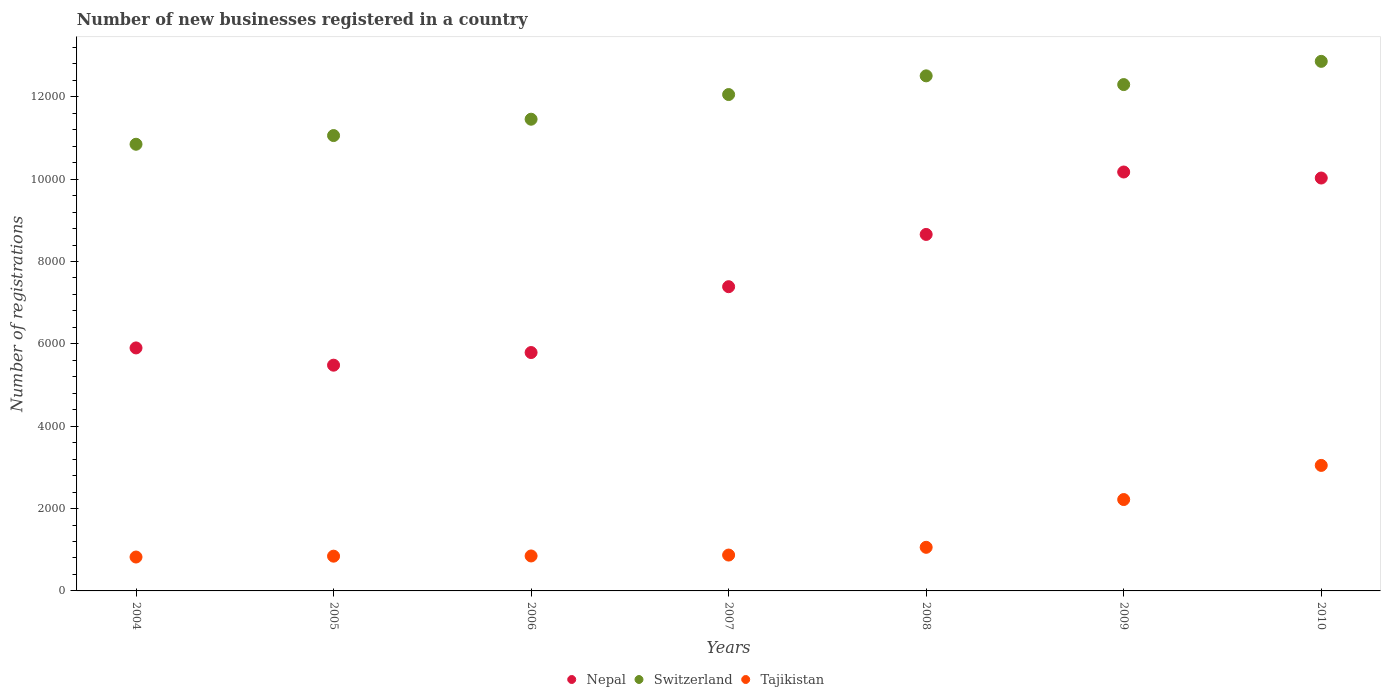What is the number of new businesses registered in Tajikistan in 2004?
Provide a succinct answer. 823. Across all years, what is the maximum number of new businesses registered in Nepal?
Provide a short and direct response. 1.02e+04. Across all years, what is the minimum number of new businesses registered in Switzerland?
Provide a succinct answer. 1.08e+04. What is the total number of new businesses registered in Nepal in the graph?
Give a very brief answer. 5.34e+04. What is the difference between the number of new businesses registered in Nepal in 2004 and that in 2008?
Offer a very short reply. -2756. What is the difference between the number of new businesses registered in Nepal in 2009 and the number of new businesses registered in Switzerland in 2010?
Your answer should be compact. -2687. What is the average number of new businesses registered in Switzerland per year?
Offer a terse response. 1.19e+04. In the year 2009, what is the difference between the number of new businesses registered in Switzerland and number of new businesses registered in Tajikistan?
Provide a succinct answer. 1.01e+04. What is the ratio of the number of new businesses registered in Nepal in 2005 to that in 2010?
Your answer should be compact. 0.55. What is the difference between the highest and the second highest number of new businesses registered in Switzerland?
Provide a succinct answer. 352. What is the difference between the highest and the lowest number of new businesses registered in Nepal?
Give a very brief answer. 4691. Is the sum of the number of new businesses registered in Nepal in 2004 and 2005 greater than the maximum number of new businesses registered in Switzerland across all years?
Provide a short and direct response. No. Does the number of new businesses registered in Switzerland monotonically increase over the years?
Give a very brief answer. No. How many dotlines are there?
Ensure brevity in your answer.  3. How many years are there in the graph?
Offer a terse response. 7. What is the difference between two consecutive major ticks on the Y-axis?
Offer a terse response. 2000. Are the values on the major ticks of Y-axis written in scientific E-notation?
Ensure brevity in your answer.  No. Where does the legend appear in the graph?
Keep it short and to the point. Bottom center. What is the title of the graph?
Ensure brevity in your answer.  Number of new businesses registered in a country. What is the label or title of the X-axis?
Your answer should be very brief. Years. What is the label or title of the Y-axis?
Your answer should be compact. Number of registrations. What is the Number of registrations in Nepal in 2004?
Provide a short and direct response. 5901. What is the Number of registrations in Switzerland in 2004?
Ensure brevity in your answer.  1.08e+04. What is the Number of registrations of Tajikistan in 2004?
Ensure brevity in your answer.  823. What is the Number of registrations in Nepal in 2005?
Provide a succinct answer. 5482. What is the Number of registrations in Switzerland in 2005?
Your response must be concise. 1.11e+04. What is the Number of registrations in Tajikistan in 2005?
Ensure brevity in your answer.  844. What is the Number of registrations of Nepal in 2006?
Your answer should be very brief. 5789. What is the Number of registrations of Switzerland in 2006?
Provide a succinct answer. 1.15e+04. What is the Number of registrations in Tajikistan in 2006?
Make the answer very short. 849. What is the Number of registrations in Nepal in 2007?
Provide a succinct answer. 7388. What is the Number of registrations of Switzerland in 2007?
Keep it short and to the point. 1.21e+04. What is the Number of registrations of Tajikistan in 2007?
Your response must be concise. 871. What is the Number of registrations of Nepal in 2008?
Ensure brevity in your answer.  8657. What is the Number of registrations in Switzerland in 2008?
Your answer should be very brief. 1.25e+04. What is the Number of registrations of Tajikistan in 2008?
Your answer should be very brief. 1059. What is the Number of registrations of Nepal in 2009?
Give a very brief answer. 1.02e+04. What is the Number of registrations in Switzerland in 2009?
Offer a very short reply. 1.23e+04. What is the Number of registrations in Tajikistan in 2009?
Make the answer very short. 2219. What is the Number of registrations in Nepal in 2010?
Your answer should be very brief. 1.00e+04. What is the Number of registrations of Switzerland in 2010?
Your response must be concise. 1.29e+04. What is the Number of registrations in Tajikistan in 2010?
Offer a terse response. 3048. Across all years, what is the maximum Number of registrations in Nepal?
Your answer should be very brief. 1.02e+04. Across all years, what is the maximum Number of registrations of Switzerland?
Provide a short and direct response. 1.29e+04. Across all years, what is the maximum Number of registrations of Tajikistan?
Your answer should be compact. 3048. Across all years, what is the minimum Number of registrations of Nepal?
Offer a very short reply. 5482. Across all years, what is the minimum Number of registrations of Switzerland?
Offer a terse response. 1.08e+04. Across all years, what is the minimum Number of registrations of Tajikistan?
Ensure brevity in your answer.  823. What is the total Number of registrations of Nepal in the graph?
Provide a short and direct response. 5.34e+04. What is the total Number of registrations of Switzerland in the graph?
Your answer should be compact. 8.31e+04. What is the total Number of registrations of Tajikistan in the graph?
Offer a terse response. 9713. What is the difference between the Number of registrations of Nepal in 2004 and that in 2005?
Your answer should be compact. 419. What is the difference between the Number of registrations in Switzerland in 2004 and that in 2005?
Provide a short and direct response. -211. What is the difference between the Number of registrations in Tajikistan in 2004 and that in 2005?
Offer a terse response. -21. What is the difference between the Number of registrations in Nepal in 2004 and that in 2006?
Keep it short and to the point. 112. What is the difference between the Number of registrations of Switzerland in 2004 and that in 2006?
Your response must be concise. -608. What is the difference between the Number of registrations of Tajikistan in 2004 and that in 2006?
Provide a short and direct response. -26. What is the difference between the Number of registrations in Nepal in 2004 and that in 2007?
Ensure brevity in your answer.  -1487. What is the difference between the Number of registrations of Switzerland in 2004 and that in 2007?
Your response must be concise. -1207. What is the difference between the Number of registrations in Tajikistan in 2004 and that in 2007?
Offer a very short reply. -48. What is the difference between the Number of registrations in Nepal in 2004 and that in 2008?
Your answer should be very brief. -2756. What is the difference between the Number of registrations in Switzerland in 2004 and that in 2008?
Provide a succinct answer. -1661. What is the difference between the Number of registrations of Tajikistan in 2004 and that in 2008?
Provide a succinct answer. -236. What is the difference between the Number of registrations in Nepal in 2004 and that in 2009?
Your answer should be very brief. -4272. What is the difference between the Number of registrations in Switzerland in 2004 and that in 2009?
Make the answer very short. -1449. What is the difference between the Number of registrations in Tajikistan in 2004 and that in 2009?
Ensure brevity in your answer.  -1396. What is the difference between the Number of registrations of Nepal in 2004 and that in 2010?
Offer a very short reply. -4126. What is the difference between the Number of registrations in Switzerland in 2004 and that in 2010?
Provide a succinct answer. -2013. What is the difference between the Number of registrations of Tajikistan in 2004 and that in 2010?
Ensure brevity in your answer.  -2225. What is the difference between the Number of registrations in Nepal in 2005 and that in 2006?
Provide a succinct answer. -307. What is the difference between the Number of registrations in Switzerland in 2005 and that in 2006?
Give a very brief answer. -397. What is the difference between the Number of registrations of Tajikistan in 2005 and that in 2006?
Your response must be concise. -5. What is the difference between the Number of registrations in Nepal in 2005 and that in 2007?
Ensure brevity in your answer.  -1906. What is the difference between the Number of registrations of Switzerland in 2005 and that in 2007?
Offer a terse response. -996. What is the difference between the Number of registrations in Tajikistan in 2005 and that in 2007?
Your answer should be very brief. -27. What is the difference between the Number of registrations of Nepal in 2005 and that in 2008?
Provide a succinct answer. -3175. What is the difference between the Number of registrations of Switzerland in 2005 and that in 2008?
Your answer should be compact. -1450. What is the difference between the Number of registrations of Tajikistan in 2005 and that in 2008?
Make the answer very short. -215. What is the difference between the Number of registrations in Nepal in 2005 and that in 2009?
Your answer should be compact. -4691. What is the difference between the Number of registrations of Switzerland in 2005 and that in 2009?
Your response must be concise. -1238. What is the difference between the Number of registrations of Tajikistan in 2005 and that in 2009?
Offer a terse response. -1375. What is the difference between the Number of registrations of Nepal in 2005 and that in 2010?
Make the answer very short. -4545. What is the difference between the Number of registrations of Switzerland in 2005 and that in 2010?
Give a very brief answer. -1802. What is the difference between the Number of registrations of Tajikistan in 2005 and that in 2010?
Your answer should be very brief. -2204. What is the difference between the Number of registrations in Nepal in 2006 and that in 2007?
Keep it short and to the point. -1599. What is the difference between the Number of registrations of Switzerland in 2006 and that in 2007?
Offer a very short reply. -599. What is the difference between the Number of registrations in Nepal in 2006 and that in 2008?
Offer a terse response. -2868. What is the difference between the Number of registrations in Switzerland in 2006 and that in 2008?
Provide a succinct answer. -1053. What is the difference between the Number of registrations in Tajikistan in 2006 and that in 2008?
Ensure brevity in your answer.  -210. What is the difference between the Number of registrations in Nepal in 2006 and that in 2009?
Make the answer very short. -4384. What is the difference between the Number of registrations of Switzerland in 2006 and that in 2009?
Your answer should be very brief. -841. What is the difference between the Number of registrations in Tajikistan in 2006 and that in 2009?
Ensure brevity in your answer.  -1370. What is the difference between the Number of registrations of Nepal in 2006 and that in 2010?
Your answer should be very brief. -4238. What is the difference between the Number of registrations in Switzerland in 2006 and that in 2010?
Offer a terse response. -1405. What is the difference between the Number of registrations in Tajikistan in 2006 and that in 2010?
Keep it short and to the point. -2199. What is the difference between the Number of registrations of Nepal in 2007 and that in 2008?
Ensure brevity in your answer.  -1269. What is the difference between the Number of registrations in Switzerland in 2007 and that in 2008?
Offer a terse response. -454. What is the difference between the Number of registrations in Tajikistan in 2007 and that in 2008?
Provide a succinct answer. -188. What is the difference between the Number of registrations of Nepal in 2007 and that in 2009?
Your answer should be compact. -2785. What is the difference between the Number of registrations in Switzerland in 2007 and that in 2009?
Provide a short and direct response. -242. What is the difference between the Number of registrations of Tajikistan in 2007 and that in 2009?
Ensure brevity in your answer.  -1348. What is the difference between the Number of registrations in Nepal in 2007 and that in 2010?
Your answer should be compact. -2639. What is the difference between the Number of registrations of Switzerland in 2007 and that in 2010?
Offer a terse response. -806. What is the difference between the Number of registrations of Tajikistan in 2007 and that in 2010?
Ensure brevity in your answer.  -2177. What is the difference between the Number of registrations of Nepal in 2008 and that in 2009?
Offer a very short reply. -1516. What is the difference between the Number of registrations of Switzerland in 2008 and that in 2009?
Give a very brief answer. 212. What is the difference between the Number of registrations in Tajikistan in 2008 and that in 2009?
Ensure brevity in your answer.  -1160. What is the difference between the Number of registrations of Nepal in 2008 and that in 2010?
Make the answer very short. -1370. What is the difference between the Number of registrations of Switzerland in 2008 and that in 2010?
Provide a succinct answer. -352. What is the difference between the Number of registrations of Tajikistan in 2008 and that in 2010?
Ensure brevity in your answer.  -1989. What is the difference between the Number of registrations of Nepal in 2009 and that in 2010?
Give a very brief answer. 146. What is the difference between the Number of registrations in Switzerland in 2009 and that in 2010?
Keep it short and to the point. -564. What is the difference between the Number of registrations in Tajikistan in 2009 and that in 2010?
Provide a succinct answer. -829. What is the difference between the Number of registrations in Nepal in 2004 and the Number of registrations in Switzerland in 2005?
Offer a terse response. -5157. What is the difference between the Number of registrations of Nepal in 2004 and the Number of registrations of Tajikistan in 2005?
Your response must be concise. 5057. What is the difference between the Number of registrations in Switzerland in 2004 and the Number of registrations in Tajikistan in 2005?
Give a very brief answer. 1.00e+04. What is the difference between the Number of registrations of Nepal in 2004 and the Number of registrations of Switzerland in 2006?
Provide a succinct answer. -5554. What is the difference between the Number of registrations of Nepal in 2004 and the Number of registrations of Tajikistan in 2006?
Your answer should be compact. 5052. What is the difference between the Number of registrations in Switzerland in 2004 and the Number of registrations in Tajikistan in 2006?
Provide a succinct answer. 9998. What is the difference between the Number of registrations in Nepal in 2004 and the Number of registrations in Switzerland in 2007?
Give a very brief answer. -6153. What is the difference between the Number of registrations of Nepal in 2004 and the Number of registrations of Tajikistan in 2007?
Give a very brief answer. 5030. What is the difference between the Number of registrations of Switzerland in 2004 and the Number of registrations of Tajikistan in 2007?
Ensure brevity in your answer.  9976. What is the difference between the Number of registrations of Nepal in 2004 and the Number of registrations of Switzerland in 2008?
Provide a short and direct response. -6607. What is the difference between the Number of registrations in Nepal in 2004 and the Number of registrations in Tajikistan in 2008?
Provide a succinct answer. 4842. What is the difference between the Number of registrations of Switzerland in 2004 and the Number of registrations of Tajikistan in 2008?
Give a very brief answer. 9788. What is the difference between the Number of registrations of Nepal in 2004 and the Number of registrations of Switzerland in 2009?
Provide a short and direct response. -6395. What is the difference between the Number of registrations in Nepal in 2004 and the Number of registrations in Tajikistan in 2009?
Provide a short and direct response. 3682. What is the difference between the Number of registrations in Switzerland in 2004 and the Number of registrations in Tajikistan in 2009?
Provide a short and direct response. 8628. What is the difference between the Number of registrations of Nepal in 2004 and the Number of registrations of Switzerland in 2010?
Keep it short and to the point. -6959. What is the difference between the Number of registrations in Nepal in 2004 and the Number of registrations in Tajikistan in 2010?
Ensure brevity in your answer.  2853. What is the difference between the Number of registrations of Switzerland in 2004 and the Number of registrations of Tajikistan in 2010?
Keep it short and to the point. 7799. What is the difference between the Number of registrations in Nepal in 2005 and the Number of registrations in Switzerland in 2006?
Provide a succinct answer. -5973. What is the difference between the Number of registrations of Nepal in 2005 and the Number of registrations of Tajikistan in 2006?
Your response must be concise. 4633. What is the difference between the Number of registrations in Switzerland in 2005 and the Number of registrations in Tajikistan in 2006?
Keep it short and to the point. 1.02e+04. What is the difference between the Number of registrations of Nepal in 2005 and the Number of registrations of Switzerland in 2007?
Make the answer very short. -6572. What is the difference between the Number of registrations in Nepal in 2005 and the Number of registrations in Tajikistan in 2007?
Give a very brief answer. 4611. What is the difference between the Number of registrations in Switzerland in 2005 and the Number of registrations in Tajikistan in 2007?
Offer a terse response. 1.02e+04. What is the difference between the Number of registrations of Nepal in 2005 and the Number of registrations of Switzerland in 2008?
Your answer should be compact. -7026. What is the difference between the Number of registrations in Nepal in 2005 and the Number of registrations in Tajikistan in 2008?
Provide a short and direct response. 4423. What is the difference between the Number of registrations of Switzerland in 2005 and the Number of registrations of Tajikistan in 2008?
Provide a succinct answer. 9999. What is the difference between the Number of registrations of Nepal in 2005 and the Number of registrations of Switzerland in 2009?
Ensure brevity in your answer.  -6814. What is the difference between the Number of registrations of Nepal in 2005 and the Number of registrations of Tajikistan in 2009?
Give a very brief answer. 3263. What is the difference between the Number of registrations of Switzerland in 2005 and the Number of registrations of Tajikistan in 2009?
Provide a short and direct response. 8839. What is the difference between the Number of registrations in Nepal in 2005 and the Number of registrations in Switzerland in 2010?
Provide a succinct answer. -7378. What is the difference between the Number of registrations of Nepal in 2005 and the Number of registrations of Tajikistan in 2010?
Your response must be concise. 2434. What is the difference between the Number of registrations of Switzerland in 2005 and the Number of registrations of Tajikistan in 2010?
Make the answer very short. 8010. What is the difference between the Number of registrations of Nepal in 2006 and the Number of registrations of Switzerland in 2007?
Provide a succinct answer. -6265. What is the difference between the Number of registrations in Nepal in 2006 and the Number of registrations in Tajikistan in 2007?
Keep it short and to the point. 4918. What is the difference between the Number of registrations in Switzerland in 2006 and the Number of registrations in Tajikistan in 2007?
Ensure brevity in your answer.  1.06e+04. What is the difference between the Number of registrations in Nepal in 2006 and the Number of registrations in Switzerland in 2008?
Your answer should be compact. -6719. What is the difference between the Number of registrations in Nepal in 2006 and the Number of registrations in Tajikistan in 2008?
Offer a terse response. 4730. What is the difference between the Number of registrations in Switzerland in 2006 and the Number of registrations in Tajikistan in 2008?
Provide a short and direct response. 1.04e+04. What is the difference between the Number of registrations in Nepal in 2006 and the Number of registrations in Switzerland in 2009?
Your answer should be very brief. -6507. What is the difference between the Number of registrations of Nepal in 2006 and the Number of registrations of Tajikistan in 2009?
Offer a terse response. 3570. What is the difference between the Number of registrations in Switzerland in 2006 and the Number of registrations in Tajikistan in 2009?
Ensure brevity in your answer.  9236. What is the difference between the Number of registrations in Nepal in 2006 and the Number of registrations in Switzerland in 2010?
Your answer should be compact. -7071. What is the difference between the Number of registrations of Nepal in 2006 and the Number of registrations of Tajikistan in 2010?
Your response must be concise. 2741. What is the difference between the Number of registrations of Switzerland in 2006 and the Number of registrations of Tajikistan in 2010?
Keep it short and to the point. 8407. What is the difference between the Number of registrations in Nepal in 2007 and the Number of registrations in Switzerland in 2008?
Ensure brevity in your answer.  -5120. What is the difference between the Number of registrations of Nepal in 2007 and the Number of registrations of Tajikistan in 2008?
Keep it short and to the point. 6329. What is the difference between the Number of registrations of Switzerland in 2007 and the Number of registrations of Tajikistan in 2008?
Your answer should be compact. 1.10e+04. What is the difference between the Number of registrations in Nepal in 2007 and the Number of registrations in Switzerland in 2009?
Your answer should be compact. -4908. What is the difference between the Number of registrations in Nepal in 2007 and the Number of registrations in Tajikistan in 2009?
Keep it short and to the point. 5169. What is the difference between the Number of registrations of Switzerland in 2007 and the Number of registrations of Tajikistan in 2009?
Your response must be concise. 9835. What is the difference between the Number of registrations in Nepal in 2007 and the Number of registrations in Switzerland in 2010?
Ensure brevity in your answer.  -5472. What is the difference between the Number of registrations of Nepal in 2007 and the Number of registrations of Tajikistan in 2010?
Keep it short and to the point. 4340. What is the difference between the Number of registrations of Switzerland in 2007 and the Number of registrations of Tajikistan in 2010?
Offer a terse response. 9006. What is the difference between the Number of registrations of Nepal in 2008 and the Number of registrations of Switzerland in 2009?
Keep it short and to the point. -3639. What is the difference between the Number of registrations in Nepal in 2008 and the Number of registrations in Tajikistan in 2009?
Give a very brief answer. 6438. What is the difference between the Number of registrations of Switzerland in 2008 and the Number of registrations of Tajikistan in 2009?
Ensure brevity in your answer.  1.03e+04. What is the difference between the Number of registrations in Nepal in 2008 and the Number of registrations in Switzerland in 2010?
Your answer should be compact. -4203. What is the difference between the Number of registrations of Nepal in 2008 and the Number of registrations of Tajikistan in 2010?
Ensure brevity in your answer.  5609. What is the difference between the Number of registrations in Switzerland in 2008 and the Number of registrations in Tajikistan in 2010?
Offer a very short reply. 9460. What is the difference between the Number of registrations in Nepal in 2009 and the Number of registrations in Switzerland in 2010?
Your answer should be very brief. -2687. What is the difference between the Number of registrations in Nepal in 2009 and the Number of registrations in Tajikistan in 2010?
Make the answer very short. 7125. What is the difference between the Number of registrations in Switzerland in 2009 and the Number of registrations in Tajikistan in 2010?
Keep it short and to the point. 9248. What is the average Number of registrations in Nepal per year?
Make the answer very short. 7631. What is the average Number of registrations in Switzerland per year?
Keep it short and to the point. 1.19e+04. What is the average Number of registrations of Tajikistan per year?
Offer a terse response. 1387.57. In the year 2004, what is the difference between the Number of registrations in Nepal and Number of registrations in Switzerland?
Make the answer very short. -4946. In the year 2004, what is the difference between the Number of registrations of Nepal and Number of registrations of Tajikistan?
Give a very brief answer. 5078. In the year 2004, what is the difference between the Number of registrations of Switzerland and Number of registrations of Tajikistan?
Provide a short and direct response. 1.00e+04. In the year 2005, what is the difference between the Number of registrations in Nepal and Number of registrations in Switzerland?
Offer a terse response. -5576. In the year 2005, what is the difference between the Number of registrations of Nepal and Number of registrations of Tajikistan?
Your response must be concise. 4638. In the year 2005, what is the difference between the Number of registrations of Switzerland and Number of registrations of Tajikistan?
Offer a very short reply. 1.02e+04. In the year 2006, what is the difference between the Number of registrations of Nepal and Number of registrations of Switzerland?
Make the answer very short. -5666. In the year 2006, what is the difference between the Number of registrations of Nepal and Number of registrations of Tajikistan?
Your answer should be compact. 4940. In the year 2006, what is the difference between the Number of registrations in Switzerland and Number of registrations in Tajikistan?
Your answer should be very brief. 1.06e+04. In the year 2007, what is the difference between the Number of registrations of Nepal and Number of registrations of Switzerland?
Provide a succinct answer. -4666. In the year 2007, what is the difference between the Number of registrations in Nepal and Number of registrations in Tajikistan?
Keep it short and to the point. 6517. In the year 2007, what is the difference between the Number of registrations of Switzerland and Number of registrations of Tajikistan?
Ensure brevity in your answer.  1.12e+04. In the year 2008, what is the difference between the Number of registrations of Nepal and Number of registrations of Switzerland?
Your answer should be very brief. -3851. In the year 2008, what is the difference between the Number of registrations of Nepal and Number of registrations of Tajikistan?
Ensure brevity in your answer.  7598. In the year 2008, what is the difference between the Number of registrations of Switzerland and Number of registrations of Tajikistan?
Offer a very short reply. 1.14e+04. In the year 2009, what is the difference between the Number of registrations of Nepal and Number of registrations of Switzerland?
Keep it short and to the point. -2123. In the year 2009, what is the difference between the Number of registrations in Nepal and Number of registrations in Tajikistan?
Your answer should be very brief. 7954. In the year 2009, what is the difference between the Number of registrations of Switzerland and Number of registrations of Tajikistan?
Offer a terse response. 1.01e+04. In the year 2010, what is the difference between the Number of registrations in Nepal and Number of registrations in Switzerland?
Offer a very short reply. -2833. In the year 2010, what is the difference between the Number of registrations in Nepal and Number of registrations in Tajikistan?
Provide a short and direct response. 6979. In the year 2010, what is the difference between the Number of registrations of Switzerland and Number of registrations of Tajikistan?
Ensure brevity in your answer.  9812. What is the ratio of the Number of registrations of Nepal in 2004 to that in 2005?
Give a very brief answer. 1.08. What is the ratio of the Number of registrations in Switzerland in 2004 to that in 2005?
Your answer should be very brief. 0.98. What is the ratio of the Number of registrations in Tajikistan in 2004 to that in 2005?
Your response must be concise. 0.98. What is the ratio of the Number of registrations in Nepal in 2004 to that in 2006?
Make the answer very short. 1.02. What is the ratio of the Number of registrations of Switzerland in 2004 to that in 2006?
Keep it short and to the point. 0.95. What is the ratio of the Number of registrations of Tajikistan in 2004 to that in 2006?
Offer a terse response. 0.97. What is the ratio of the Number of registrations of Nepal in 2004 to that in 2007?
Offer a terse response. 0.8. What is the ratio of the Number of registrations of Switzerland in 2004 to that in 2007?
Give a very brief answer. 0.9. What is the ratio of the Number of registrations in Tajikistan in 2004 to that in 2007?
Provide a short and direct response. 0.94. What is the ratio of the Number of registrations of Nepal in 2004 to that in 2008?
Provide a short and direct response. 0.68. What is the ratio of the Number of registrations in Switzerland in 2004 to that in 2008?
Give a very brief answer. 0.87. What is the ratio of the Number of registrations in Tajikistan in 2004 to that in 2008?
Keep it short and to the point. 0.78. What is the ratio of the Number of registrations of Nepal in 2004 to that in 2009?
Give a very brief answer. 0.58. What is the ratio of the Number of registrations in Switzerland in 2004 to that in 2009?
Provide a short and direct response. 0.88. What is the ratio of the Number of registrations of Tajikistan in 2004 to that in 2009?
Make the answer very short. 0.37. What is the ratio of the Number of registrations in Nepal in 2004 to that in 2010?
Your answer should be very brief. 0.59. What is the ratio of the Number of registrations in Switzerland in 2004 to that in 2010?
Make the answer very short. 0.84. What is the ratio of the Number of registrations of Tajikistan in 2004 to that in 2010?
Offer a terse response. 0.27. What is the ratio of the Number of registrations of Nepal in 2005 to that in 2006?
Give a very brief answer. 0.95. What is the ratio of the Number of registrations of Switzerland in 2005 to that in 2006?
Ensure brevity in your answer.  0.97. What is the ratio of the Number of registrations in Tajikistan in 2005 to that in 2006?
Offer a terse response. 0.99. What is the ratio of the Number of registrations in Nepal in 2005 to that in 2007?
Provide a succinct answer. 0.74. What is the ratio of the Number of registrations in Switzerland in 2005 to that in 2007?
Offer a very short reply. 0.92. What is the ratio of the Number of registrations in Tajikistan in 2005 to that in 2007?
Your answer should be compact. 0.97. What is the ratio of the Number of registrations of Nepal in 2005 to that in 2008?
Provide a succinct answer. 0.63. What is the ratio of the Number of registrations of Switzerland in 2005 to that in 2008?
Ensure brevity in your answer.  0.88. What is the ratio of the Number of registrations of Tajikistan in 2005 to that in 2008?
Offer a very short reply. 0.8. What is the ratio of the Number of registrations of Nepal in 2005 to that in 2009?
Make the answer very short. 0.54. What is the ratio of the Number of registrations of Switzerland in 2005 to that in 2009?
Your answer should be compact. 0.9. What is the ratio of the Number of registrations in Tajikistan in 2005 to that in 2009?
Provide a short and direct response. 0.38. What is the ratio of the Number of registrations of Nepal in 2005 to that in 2010?
Offer a terse response. 0.55. What is the ratio of the Number of registrations in Switzerland in 2005 to that in 2010?
Your answer should be very brief. 0.86. What is the ratio of the Number of registrations of Tajikistan in 2005 to that in 2010?
Make the answer very short. 0.28. What is the ratio of the Number of registrations of Nepal in 2006 to that in 2007?
Offer a very short reply. 0.78. What is the ratio of the Number of registrations in Switzerland in 2006 to that in 2007?
Give a very brief answer. 0.95. What is the ratio of the Number of registrations in Tajikistan in 2006 to that in 2007?
Keep it short and to the point. 0.97. What is the ratio of the Number of registrations in Nepal in 2006 to that in 2008?
Your answer should be very brief. 0.67. What is the ratio of the Number of registrations of Switzerland in 2006 to that in 2008?
Provide a succinct answer. 0.92. What is the ratio of the Number of registrations in Tajikistan in 2006 to that in 2008?
Provide a short and direct response. 0.8. What is the ratio of the Number of registrations in Nepal in 2006 to that in 2009?
Offer a very short reply. 0.57. What is the ratio of the Number of registrations in Switzerland in 2006 to that in 2009?
Offer a very short reply. 0.93. What is the ratio of the Number of registrations of Tajikistan in 2006 to that in 2009?
Offer a terse response. 0.38. What is the ratio of the Number of registrations of Nepal in 2006 to that in 2010?
Provide a short and direct response. 0.58. What is the ratio of the Number of registrations in Switzerland in 2006 to that in 2010?
Offer a very short reply. 0.89. What is the ratio of the Number of registrations of Tajikistan in 2006 to that in 2010?
Make the answer very short. 0.28. What is the ratio of the Number of registrations in Nepal in 2007 to that in 2008?
Offer a very short reply. 0.85. What is the ratio of the Number of registrations in Switzerland in 2007 to that in 2008?
Offer a terse response. 0.96. What is the ratio of the Number of registrations of Tajikistan in 2007 to that in 2008?
Keep it short and to the point. 0.82. What is the ratio of the Number of registrations in Nepal in 2007 to that in 2009?
Provide a short and direct response. 0.73. What is the ratio of the Number of registrations in Switzerland in 2007 to that in 2009?
Keep it short and to the point. 0.98. What is the ratio of the Number of registrations of Tajikistan in 2007 to that in 2009?
Your answer should be compact. 0.39. What is the ratio of the Number of registrations in Nepal in 2007 to that in 2010?
Make the answer very short. 0.74. What is the ratio of the Number of registrations in Switzerland in 2007 to that in 2010?
Offer a terse response. 0.94. What is the ratio of the Number of registrations in Tajikistan in 2007 to that in 2010?
Ensure brevity in your answer.  0.29. What is the ratio of the Number of registrations in Nepal in 2008 to that in 2009?
Provide a short and direct response. 0.85. What is the ratio of the Number of registrations in Switzerland in 2008 to that in 2009?
Your response must be concise. 1.02. What is the ratio of the Number of registrations in Tajikistan in 2008 to that in 2009?
Your answer should be very brief. 0.48. What is the ratio of the Number of registrations of Nepal in 2008 to that in 2010?
Give a very brief answer. 0.86. What is the ratio of the Number of registrations in Switzerland in 2008 to that in 2010?
Provide a short and direct response. 0.97. What is the ratio of the Number of registrations in Tajikistan in 2008 to that in 2010?
Give a very brief answer. 0.35. What is the ratio of the Number of registrations of Nepal in 2009 to that in 2010?
Provide a succinct answer. 1.01. What is the ratio of the Number of registrations of Switzerland in 2009 to that in 2010?
Make the answer very short. 0.96. What is the ratio of the Number of registrations in Tajikistan in 2009 to that in 2010?
Provide a succinct answer. 0.73. What is the difference between the highest and the second highest Number of registrations of Nepal?
Offer a very short reply. 146. What is the difference between the highest and the second highest Number of registrations in Switzerland?
Offer a very short reply. 352. What is the difference between the highest and the second highest Number of registrations in Tajikistan?
Your response must be concise. 829. What is the difference between the highest and the lowest Number of registrations of Nepal?
Your answer should be very brief. 4691. What is the difference between the highest and the lowest Number of registrations in Switzerland?
Your response must be concise. 2013. What is the difference between the highest and the lowest Number of registrations of Tajikistan?
Offer a very short reply. 2225. 